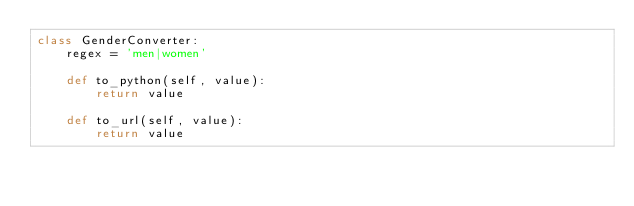Convert code to text. <code><loc_0><loc_0><loc_500><loc_500><_Python_>class GenderConverter:
    regex = 'men|women'

    def to_python(self, value):
        return value

    def to_url(self, value):
        return value
</code> 